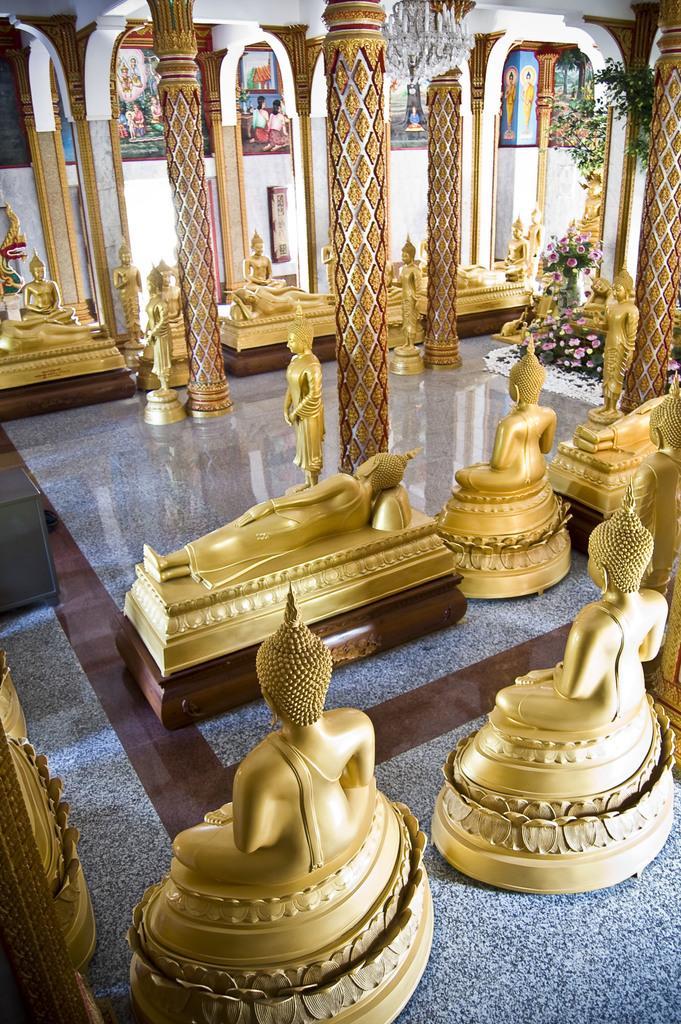How would you summarize this image in a sentence or two? In this image, we can see some mini statues on the granite surface. We can see some poles, plants and the wall with some frames. 